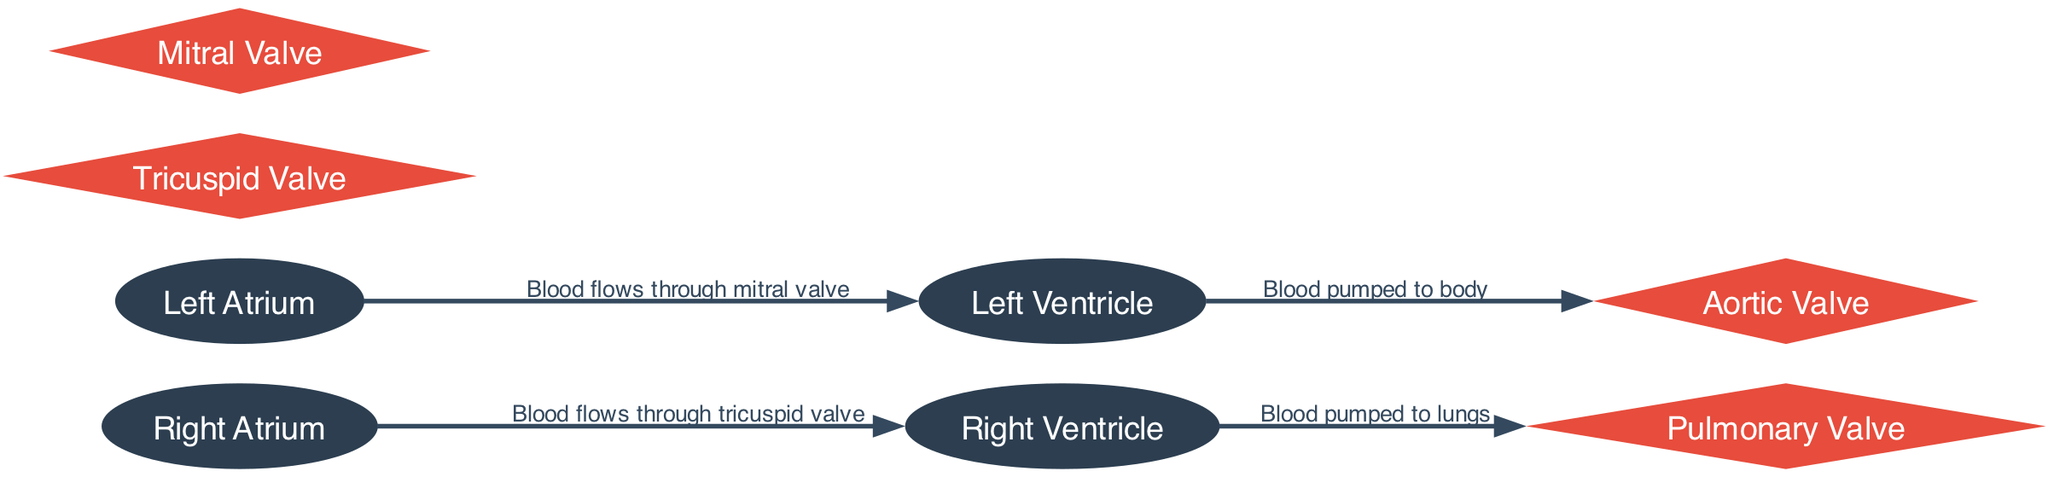What are the four main chambers of the heart depicted in the diagram? The diagram shows four main chambers: the right atrium, right ventricle, left atrium, and left ventricle. They are explicitly named as nodes in the diagram.
Answer: right atrium, right ventricle, left atrium, left ventricle Which valve is located between the right atrium and right ventricle? The diagram specifies the flow of blood from the right atrium to the right ventricle through the tricuspid valve. This relationship is shown as an edge connecting those nodes.
Answer: Tricuspid Valve What type of blood is pumped to the lungs from the right ventricle? The diagram indicates that blood is pumped from the right ventricle to the lungs, which involves deoxygenated blood returning from the body. This context can be inferred from the connection between the right ventricle and the pulmonary valve.
Answer: Deoxygenated How many valves are depicted in the diagram? The diagram includes four valves: tricuspid valve, pulmonary valve, mitral valve, and aortic valve, all represented as nodes with their specific labels. Therefore, counting them gives the total.
Answer: 4 What is the flow direction of blood from the left ventricle to the body? The diagram shows that blood is pumped from the left ventricle through the aortic valve to the body. This flow is indicated by the edge connecting the left ventricle to the aortic valve.
Answer: Blood pumped to body Which atrium does blood enter before flowing into the left ventricle? According to the diagram, blood enters from the left atrium and flows through the mitral valve into the left ventricle. This sequential order is shown through directed edges in the diagram.
Answer: Left Atrium What is the relationship between the pulmonary valve and blood flow? The diagram depicts that blood is pumped to the lungs from the right ventricle through the pulmonary valve. This is represented as an edge connecting the right ventricle to the pulmonary valve, indicating the crucial function of the pulmonary valve in this process.
Answer: Blood pumped to lungs Which valve separates the left atrium from the left ventricle? The diagram indicates that the flow of blood from the left atrium to the left ventricle occurs through the mitral valve. This specific relationship is clearly labeled in the diagram.
Answer: Mitral Valve How many edges are present in the diagram illustrating the cardiac cycle? By analyzing the diagram, there are four edges that represent the flow of blood between the heart chambers and valves. Each edge corresponds to a specific flow described in the diagram and counts up to four.
Answer: 4 